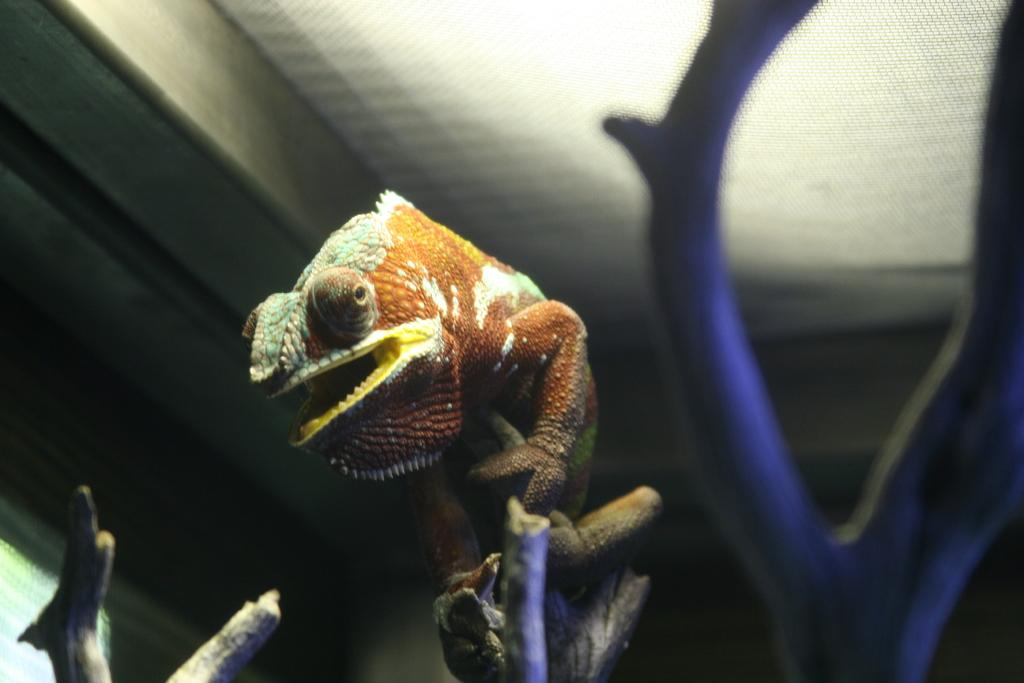What type of animal can be seen in the image? There is a lizard in the image. Where is the lizard located in the image? The lizard is on the stem of a plant. What is visible at the top of the image? There is a ceiling visible at the top of the image. What type of jelly can be seen floating in the air in the image? There is no jelly present in the image; it only features a lizard on a plant stem and a ceiling. 